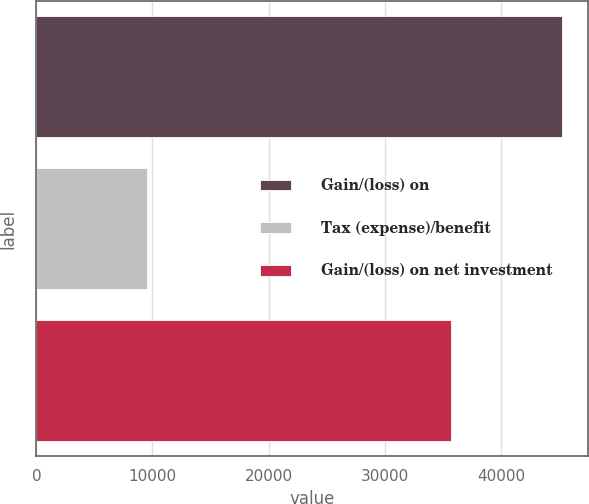Convert chart. <chart><loc_0><loc_0><loc_500><loc_500><bar_chart><fcel>Gain/(loss) on<fcel>Tax (expense)/benefit<fcel>Gain/(loss) on net investment<nl><fcel>45230<fcel>9498<fcel>35732<nl></chart> 